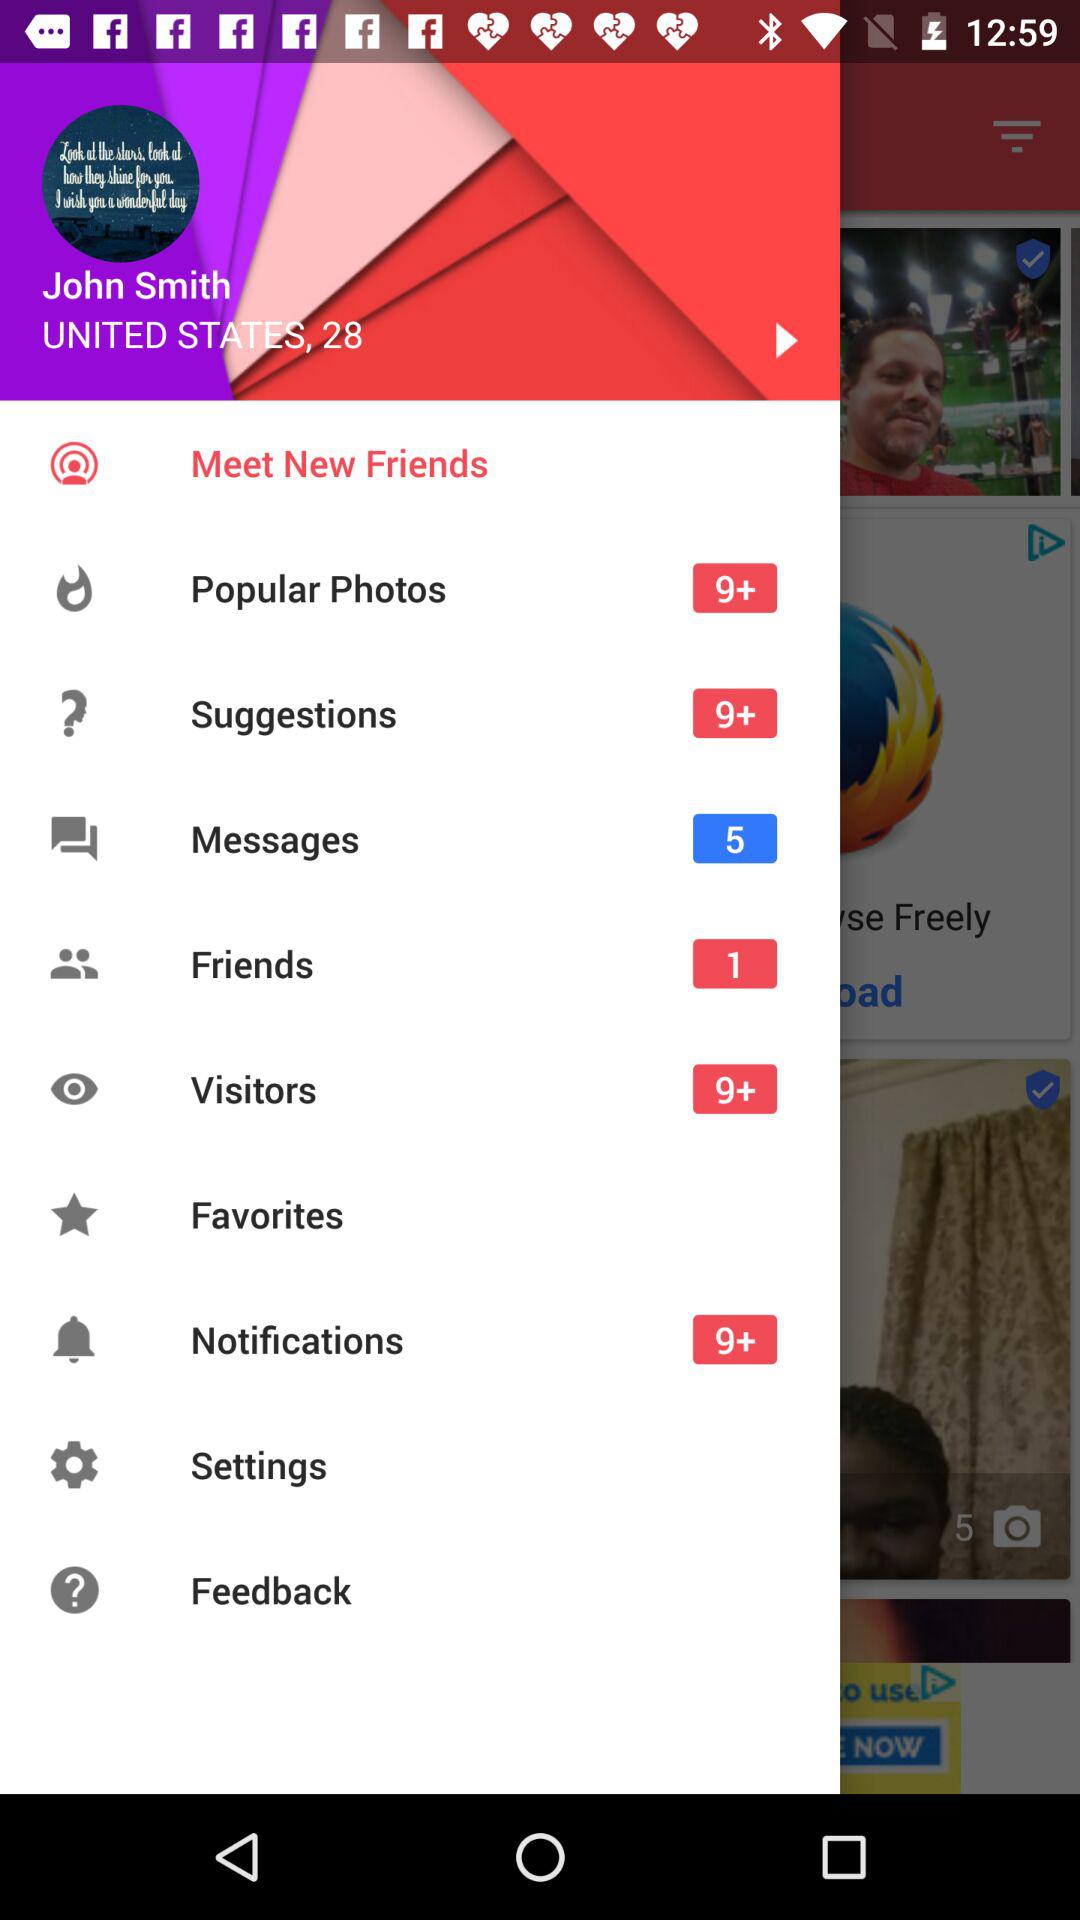Are there any unread messages? There are 5 unread messages. 